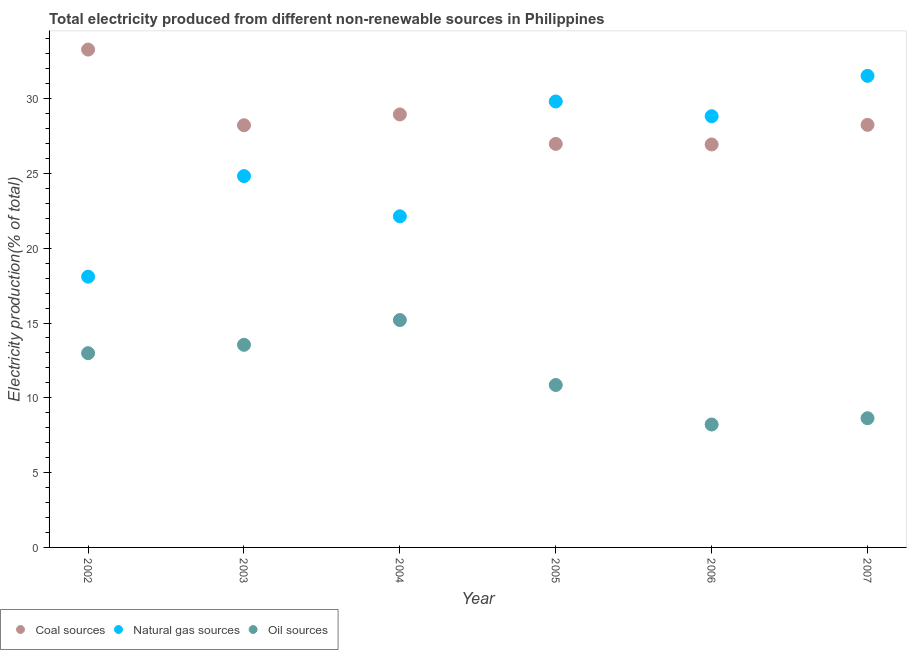How many different coloured dotlines are there?
Provide a short and direct response. 3. What is the percentage of electricity produced by oil sources in 2002?
Your answer should be very brief. 12.98. Across all years, what is the maximum percentage of electricity produced by coal?
Ensure brevity in your answer.  33.28. Across all years, what is the minimum percentage of electricity produced by coal?
Ensure brevity in your answer.  26.93. In which year was the percentage of electricity produced by coal maximum?
Give a very brief answer. 2002. What is the total percentage of electricity produced by coal in the graph?
Ensure brevity in your answer.  172.59. What is the difference between the percentage of electricity produced by natural gas in 2002 and that in 2006?
Ensure brevity in your answer.  -10.73. What is the difference between the percentage of electricity produced by coal in 2007 and the percentage of electricity produced by natural gas in 2006?
Your answer should be very brief. -0.58. What is the average percentage of electricity produced by oil sources per year?
Make the answer very short. 11.57. In the year 2006, what is the difference between the percentage of electricity produced by natural gas and percentage of electricity produced by oil sources?
Give a very brief answer. 20.61. In how many years, is the percentage of electricity produced by natural gas greater than 25 %?
Offer a very short reply. 3. What is the ratio of the percentage of electricity produced by natural gas in 2006 to that in 2007?
Offer a terse response. 0.91. What is the difference between the highest and the second highest percentage of electricity produced by coal?
Give a very brief answer. 4.34. What is the difference between the highest and the lowest percentage of electricity produced by coal?
Your answer should be very brief. 6.34. Is it the case that in every year, the sum of the percentage of electricity produced by coal and percentage of electricity produced by natural gas is greater than the percentage of electricity produced by oil sources?
Keep it short and to the point. Yes. Does the percentage of electricity produced by natural gas monotonically increase over the years?
Offer a terse response. No. Is the percentage of electricity produced by oil sources strictly less than the percentage of electricity produced by coal over the years?
Provide a short and direct response. Yes. What is the difference between two consecutive major ticks on the Y-axis?
Offer a terse response. 5. Are the values on the major ticks of Y-axis written in scientific E-notation?
Your answer should be compact. No. Does the graph contain any zero values?
Give a very brief answer. No. What is the title of the graph?
Offer a very short reply. Total electricity produced from different non-renewable sources in Philippines. Does "Ages 20-50" appear as one of the legend labels in the graph?
Offer a very short reply. No. What is the Electricity production(% of total) of Coal sources in 2002?
Offer a very short reply. 33.28. What is the Electricity production(% of total) in Natural gas sources in 2002?
Offer a terse response. 18.1. What is the Electricity production(% of total) of Oil sources in 2002?
Provide a succinct answer. 12.98. What is the Electricity production(% of total) in Coal sources in 2003?
Your answer should be very brief. 28.22. What is the Electricity production(% of total) in Natural gas sources in 2003?
Your answer should be very brief. 24.82. What is the Electricity production(% of total) in Oil sources in 2003?
Your answer should be very brief. 13.54. What is the Electricity production(% of total) of Coal sources in 2004?
Provide a succinct answer. 28.94. What is the Electricity production(% of total) in Natural gas sources in 2004?
Ensure brevity in your answer.  22.13. What is the Electricity production(% of total) of Oil sources in 2004?
Provide a succinct answer. 15.2. What is the Electricity production(% of total) in Coal sources in 2005?
Offer a terse response. 26.97. What is the Electricity production(% of total) in Natural gas sources in 2005?
Ensure brevity in your answer.  29.81. What is the Electricity production(% of total) in Oil sources in 2005?
Offer a terse response. 10.86. What is the Electricity production(% of total) in Coal sources in 2006?
Give a very brief answer. 26.93. What is the Electricity production(% of total) in Natural gas sources in 2006?
Provide a short and direct response. 28.82. What is the Electricity production(% of total) in Oil sources in 2006?
Your response must be concise. 8.22. What is the Electricity production(% of total) in Coal sources in 2007?
Your answer should be compact. 28.24. What is the Electricity production(% of total) of Natural gas sources in 2007?
Provide a short and direct response. 31.52. What is the Electricity production(% of total) in Oil sources in 2007?
Offer a very short reply. 8.64. Across all years, what is the maximum Electricity production(% of total) in Coal sources?
Your answer should be very brief. 33.28. Across all years, what is the maximum Electricity production(% of total) in Natural gas sources?
Give a very brief answer. 31.52. Across all years, what is the maximum Electricity production(% of total) in Oil sources?
Ensure brevity in your answer.  15.2. Across all years, what is the minimum Electricity production(% of total) of Coal sources?
Offer a terse response. 26.93. Across all years, what is the minimum Electricity production(% of total) of Natural gas sources?
Provide a short and direct response. 18.1. Across all years, what is the minimum Electricity production(% of total) of Oil sources?
Your answer should be very brief. 8.22. What is the total Electricity production(% of total) of Coal sources in the graph?
Ensure brevity in your answer.  172.59. What is the total Electricity production(% of total) of Natural gas sources in the graph?
Ensure brevity in your answer.  155.2. What is the total Electricity production(% of total) in Oil sources in the graph?
Give a very brief answer. 69.43. What is the difference between the Electricity production(% of total) in Coal sources in 2002 and that in 2003?
Make the answer very short. 5.06. What is the difference between the Electricity production(% of total) in Natural gas sources in 2002 and that in 2003?
Give a very brief answer. -6.72. What is the difference between the Electricity production(% of total) of Oil sources in 2002 and that in 2003?
Keep it short and to the point. -0.56. What is the difference between the Electricity production(% of total) of Coal sources in 2002 and that in 2004?
Your answer should be compact. 4.34. What is the difference between the Electricity production(% of total) of Natural gas sources in 2002 and that in 2004?
Your answer should be very brief. -4.03. What is the difference between the Electricity production(% of total) in Oil sources in 2002 and that in 2004?
Ensure brevity in your answer.  -2.21. What is the difference between the Electricity production(% of total) in Coal sources in 2002 and that in 2005?
Provide a short and direct response. 6.3. What is the difference between the Electricity production(% of total) in Natural gas sources in 2002 and that in 2005?
Offer a very short reply. -11.71. What is the difference between the Electricity production(% of total) in Oil sources in 2002 and that in 2005?
Provide a succinct answer. 2.13. What is the difference between the Electricity production(% of total) of Coal sources in 2002 and that in 2006?
Offer a terse response. 6.34. What is the difference between the Electricity production(% of total) in Natural gas sources in 2002 and that in 2006?
Make the answer very short. -10.73. What is the difference between the Electricity production(% of total) of Oil sources in 2002 and that in 2006?
Your response must be concise. 4.77. What is the difference between the Electricity production(% of total) in Coal sources in 2002 and that in 2007?
Your answer should be very brief. 5.03. What is the difference between the Electricity production(% of total) of Natural gas sources in 2002 and that in 2007?
Your response must be concise. -13.42. What is the difference between the Electricity production(% of total) in Oil sources in 2002 and that in 2007?
Your response must be concise. 4.35. What is the difference between the Electricity production(% of total) of Coal sources in 2003 and that in 2004?
Make the answer very short. -0.72. What is the difference between the Electricity production(% of total) of Natural gas sources in 2003 and that in 2004?
Make the answer very short. 2.69. What is the difference between the Electricity production(% of total) in Oil sources in 2003 and that in 2004?
Offer a terse response. -1.65. What is the difference between the Electricity production(% of total) of Coal sources in 2003 and that in 2005?
Offer a terse response. 1.25. What is the difference between the Electricity production(% of total) in Natural gas sources in 2003 and that in 2005?
Provide a succinct answer. -4.99. What is the difference between the Electricity production(% of total) in Oil sources in 2003 and that in 2005?
Provide a short and direct response. 2.69. What is the difference between the Electricity production(% of total) of Coal sources in 2003 and that in 2006?
Give a very brief answer. 1.28. What is the difference between the Electricity production(% of total) of Natural gas sources in 2003 and that in 2006?
Your answer should be very brief. -4. What is the difference between the Electricity production(% of total) in Oil sources in 2003 and that in 2006?
Give a very brief answer. 5.33. What is the difference between the Electricity production(% of total) in Coal sources in 2003 and that in 2007?
Ensure brevity in your answer.  -0.03. What is the difference between the Electricity production(% of total) in Natural gas sources in 2003 and that in 2007?
Offer a very short reply. -6.7. What is the difference between the Electricity production(% of total) of Oil sources in 2003 and that in 2007?
Ensure brevity in your answer.  4.91. What is the difference between the Electricity production(% of total) in Coal sources in 2004 and that in 2005?
Offer a terse response. 1.97. What is the difference between the Electricity production(% of total) in Natural gas sources in 2004 and that in 2005?
Ensure brevity in your answer.  -7.68. What is the difference between the Electricity production(% of total) of Oil sources in 2004 and that in 2005?
Your answer should be compact. 4.34. What is the difference between the Electricity production(% of total) in Coal sources in 2004 and that in 2006?
Keep it short and to the point. 2.01. What is the difference between the Electricity production(% of total) in Natural gas sources in 2004 and that in 2006?
Provide a short and direct response. -6.69. What is the difference between the Electricity production(% of total) in Oil sources in 2004 and that in 2006?
Provide a succinct answer. 6.98. What is the difference between the Electricity production(% of total) of Coal sources in 2004 and that in 2007?
Give a very brief answer. 0.7. What is the difference between the Electricity production(% of total) in Natural gas sources in 2004 and that in 2007?
Offer a very short reply. -9.39. What is the difference between the Electricity production(% of total) in Oil sources in 2004 and that in 2007?
Offer a terse response. 6.56. What is the difference between the Electricity production(% of total) in Coal sources in 2005 and that in 2006?
Your answer should be very brief. 0.04. What is the difference between the Electricity production(% of total) in Natural gas sources in 2005 and that in 2006?
Your response must be concise. 0.99. What is the difference between the Electricity production(% of total) in Oil sources in 2005 and that in 2006?
Give a very brief answer. 2.64. What is the difference between the Electricity production(% of total) in Coal sources in 2005 and that in 2007?
Give a very brief answer. -1.27. What is the difference between the Electricity production(% of total) of Natural gas sources in 2005 and that in 2007?
Offer a very short reply. -1.71. What is the difference between the Electricity production(% of total) of Oil sources in 2005 and that in 2007?
Your answer should be compact. 2.22. What is the difference between the Electricity production(% of total) of Coal sources in 2006 and that in 2007?
Provide a short and direct response. -1.31. What is the difference between the Electricity production(% of total) in Natural gas sources in 2006 and that in 2007?
Give a very brief answer. -2.7. What is the difference between the Electricity production(% of total) of Oil sources in 2006 and that in 2007?
Provide a short and direct response. -0.42. What is the difference between the Electricity production(% of total) of Coal sources in 2002 and the Electricity production(% of total) of Natural gas sources in 2003?
Offer a terse response. 8.46. What is the difference between the Electricity production(% of total) in Coal sources in 2002 and the Electricity production(% of total) in Oil sources in 2003?
Keep it short and to the point. 19.73. What is the difference between the Electricity production(% of total) in Natural gas sources in 2002 and the Electricity production(% of total) in Oil sources in 2003?
Your answer should be very brief. 4.55. What is the difference between the Electricity production(% of total) of Coal sources in 2002 and the Electricity production(% of total) of Natural gas sources in 2004?
Make the answer very short. 11.14. What is the difference between the Electricity production(% of total) of Coal sources in 2002 and the Electricity production(% of total) of Oil sources in 2004?
Make the answer very short. 18.08. What is the difference between the Electricity production(% of total) in Natural gas sources in 2002 and the Electricity production(% of total) in Oil sources in 2004?
Your answer should be compact. 2.9. What is the difference between the Electricity production(% of total) of Coal sources in 2002 and the Electricity production(% of total) of Natural gas sources in 2005?
Give a very brief answer. 3.47. What is the difference between the Electricity production(% of total) in Coal sources in 2002 and the Electricity production(% of total) in Oil sources in 2005?
Your response must be concise. 22.42. What is the difference between the Electricity production(% of total) of Natural gas sources in 2002 and the Electricity production(% of total) of Oil sources in 2005?
Ensure brevity in your answer.  7.24. What is the difference between the Electricity production(% of total) of Coal sources in 2002 and the Electricity production(% of total) of Natural gas sources in 2006?
Offer a terse response. 4.45. What is the difference between the Electricity production(% of total) of Coal sources in 2002 and the Electricity production(% of total) of Oil sources in 2006?
Give a very brief answer. 25.06. What is the difference between the Electricity production(% of total) of Natural gas sources in 2002 and the Electricity production(% of total) of Oil sources in 2006?
Keep it short and to the point. 9.88. What is the difference between the Electricity production(% of total) of Coal sources in 2002 and the Electricity production(% of total) of Natural gas sources in 2007?
Ensure brevity in your answer.  1.76. What is the difference between the Electricity production(% of total) of Coal sources in 2002 and the Electricity production(% of total) of Oil sources in 2007?
Offer a terse response. 24.64. What is the difference between the Electricity production(% of total) of Natural gas sources in 2002 and the Electricity production(% of total) of Oil sources in 2007?
Keep it short and to the point. 9.46. What is the difference between the Electricity production(% of total) in Coal sources in 2003 and the Electricity production(% of total) in Natural gas sources in 2004?
Make the answer very short. 6.09. What is the difference between the Electricity production(% of total) of Coal sources in 2003 and the Electricity production(% of total) of Oil sources in 2004?
Keep it short and to the point. 13.02. What is the difference between the Electricity production(% of total) of Natural gas sources in 2003 and the Electricity production(% of total) of Oil sources in 2004?
Make the answer very short. 9.62. What is the difference between the Electricity production(% of total) of Coal sources in 2003 and the Electricity production(% of total) of Natural gas sources in 2005?
Ensure brevity in your answer.  -1.59. What is the difference between the Electricity production(% of total) in Coal sources in 2003 and the Electricity production(% of total) in Oil sources in 2005?
Your response must be concise. 17.36. What is the difference between the Electricity production(% of total) in Natural gas sources in 2003 and the Electricity production(% of total) in Oil sources in 2005?
Your response must be concise. 13.96. What is the difference between the Electricity production(% of total) in Coal sources in 2003 and the Electricity production(% of total) in Natural gas sources in 2006?
Offer a terse response. -0.6. What is the difference between the Electricity production(% of total) in Coal sources in 2003 and the Electricity production(% of total) in Oil sources in 2006?
Offer a very short reply. 20. What is the difference between the Electricity production(% of total) of Natural gas sources in 2003 and the Electricity production(% of total) of Oil sources in 2006?
Provide a succinct answer. 16.6. What is the difference between the Electricity production(% of total) in Coal sources in 2003 and the Electricity production(% of total) in Natural gas sources in 2007?
Make the answer very short. -3.3. What is the difference between the Electricity production(% of total) of Coal sources in 2003 and the Electricity production(% of total) of Oil sources in 2007?
Provide a short and direct response. 19.58. What is the difference between the Electricity production(% of total) of Natural gas sources in 2003 and the Electricity production(% of total) of Oil sources in 2007?
Your answer should be very brief. 16.18. What is the difference between the Electricity production(% of total) of Coal sources in 2004 and the Electricity production(% of total) of Natural gas sources in 2005?
Keep it short and to the point. -0.87. What is the difference between the Electricity production(% of total) in Coal sources in 2004 and the Electricity production(% of total) in Oil sources in 2005?
Provide a succinct answer. 18.08. What is the difference between the Electricity production(% of total) in Natural gas sources in 2004 and the Electricity production(% of total) in Oil sources in 2005?
Your response must be concise. 11.28. What is the difference between the Electricity production(% of total) of Coal sources in 2004 and the Electricity production(% of total) of Natural gas sources in 2006?
Keep it short and to the point. 0.12. What is the difference between the Electricity production(% of total) in Coal sources in 2004 and the Electricity production(% of total) in Oil sources in 2006?
Your answer should be very brief. 20.72. What is the difference between the Electricity production(% of total) of Natural gas sources in 2004 and the Electricity production(% of total) of Oil sources in 2006?
Provide a succinct answer. 13.92. What is the difference between the Electricity production(% of total) of Coal sources in 2004 and the Electricity production(% of total) of Natural gas sources in 2007?
Your answer should be compact. -2.58. What is the difference between the Electricity production(% of total) of Coal sources in 2004 and the Electricity production(% of total) of Oil sources in 2007?
Provide a short and direct response. 20.3. What is the difference between the Electricity production(% of total) of Natural gas sources in 2004 and the Electricity production(% of total) of Oil sources in 2007?
Make the answer very short. 13.5. What is the difference between the Electricity production(% of total) of Coal sources in 2005 and the Electricity production(% of total) of Natural gas sources in 2006?
Keep it short and to the point. -1.85. What is the difference between the Electricity production(% of total) in Coal sources in 2005 and the Electricity production(% of total) in Oil sources in 2006?
Your answer should be very brief. 18.76. What is the difference between the Electricity production(% of total) in Natural gas sources in 2005 and the Electricity production(% of total) in Oil sources in 2006?
Your answer should be compact. 21.59. What is the difference between the Electricity production(% of total) of Coal sources in 2005 and the Electricity production(% of total) of Natural gas sources in 2007?
Offer a terse response. -4.55. What is the difference between the Electricity production(% of total) of Coal sources in 2005 and the Electricity production(% of total) of Oil sources in 2007?
Provide a short and direct response. 18.34. What is the difference between the Electricity production(% of total) in Natural gas sources in 2005 and the Electricity production(% of total) in Oil sources in 2007?
Your response must be concise. 21.17. What is the difference between the Electricity production(% of total) in Coal sources in 2006 and the Electricity production(% of total) in Natural gas sources in 2007?
Provide a short and direct response. -4.59. What is the difference between the Electricity production(% of total) in Coal sources in 2006 and the Electricity production(% of total) in Oil sources in 2007?
Offer a very short reply. 18.3. What is the difference between the Electricity production(% of total) of Natural gas sources in 2006 and the Electricity production(% of total) of Oil sources in 2007?
Provide a succinct answer. 20.19. What is the average Electricity production(% of total) of Coal sources per year?
Offer a terse response. 28.76. What is the average Electricity production(% of total) in Natural gas sources per year?
Make the answer very short. 25.87. What is the average Electricity production(% of total) in Oil sources per year?
Your answer should be very brief. 11.57. In the year 2002, what is the difference between the Electricity production(% of total) in Coal sources and Electricity production(% of total) in Natural gas sources?
Your response must be concise. 15.18. In the year 2002, what is the difference between the Electricity production(% of total) in Coal sources and Electricity production(% of total) in Oil sources?
Give a very brief answer. 20.29. In the year 2002, what is the difference between the Electricity production(% of total) in Natural gas sources and Electricity production(% of total) in Oil sources?
Provide a succinct answer. 5.11. In the year 2003, what is the difference between the Electricity production(% of total) of Coal sources and Electricity production(% of total) of Natural gas sources?
Provide a short and direct response. 3.4. In the year 2003, what is the difference between the Electricity production(% of total) in Coal sources and Electricity production(% of total) in Oil sources?
Make the answer very short. 14.68. In the year 2003, what is the difference between the Electricity production(% of total) of Natural gas sources and Electricity production(% of total) of Oil sources?
Keep it short and to the point. 11.28. In the year 2004, what is the difference between the Electricity production(% of total) in Coal sources and Electricity production(% of total) in Natural gas sources?
Provide a succinct answer. 6.81. In the year 2004, what is the difference between the Electricity production(% of total) of Coal sources and Electricity production(% of total) of Oil sources?
Make the answer very short. 13.74. In the year 2004, what is the difference between the Electricity production(% of total) of Natural gas sources and Electricity production(% of total) of Oil sources?
Provide a short and direct response. 6.93. In the year 2005, what is the difference between the Electricity production(% of total) of Coal sources and Electricity production(% of total) of Natural gas sources?
Provide a succinct answer. -2.84. In the year 2005, what is the difference between the Electricity production(% of total) of Coal sources and Electricity production(% of total) of Oil sources?
Offer a terse response. 16.12. In the year 2005, what is the difference between the Electricity production(% of total) of Natural gas sources and Electricity production(% of total) of Oil sources?
Provide a short and direct response. 18.95. In the year 2006, what is the difference between the Electricity production(% of total) of Coal sources and Electricity production(% of total) of Natural gas sources?
Provide a succinct answer. -1.89. In the year 2006, what is the difference between the Electricity production(% of total) in Coal sources and Electricity production(% of total) in Oil sources?
Make the answer very short. 18.72. In the year 2006, what is the difference between the Electricity production(% of total) of Natural gas sources and Electricity production(% of total) of Oil sources?
Your answer should be very brief. 20.61. In the year 2007, what is the difference between the Electricity production(% of total) of Coal sources and Electricity production(% of total) of Natural gas sources?
Offer a very short reply. -3.27. In the year 2007, what is the difference between the Electricity production(% of total) in Coal sources and Electricity production(% of total) in Oil sources?
Make the answer very short. 19.61. In the year 2007, what is the difference between the Electricity production(% of total) of Natural gas sources and Electricity production(% of total) of Oil sources?
Your response must be concise. 22.88. What is the ratio of the Electricity production(% of total) in Coal sources in 2002 to that in 2003?
Your answer should be very brief. 1.18. What is the ratio of the Electricity production(% of total) in Natural gas sources in 2002 to that in 2003?
Offer a very short reply. 0.73. What is the ratio of the Electricity production(% of total) in Oil sources in 2002 to that in 2003?
Your answer should be very brief. 0.96. What is the ratio of the Electricity production(% of total) of Coal sources in 2002 to that in 2004?
Ensure brevity in your answer.  1.15. What is the ratio of the Electricity production(% of total) of Natural gas sources in 2002 to that in 2004?
Give a very brief answer. 0.82. What is the ratio of the Electricity production(% of total) of Oil sources in 2002 to that in 2004?
Provide a short and direct response. 0.85. What is the ratio of the Electricity production(% of total) of Coal sources in 2002 to that in 2005?
Offer a very short reply. 1.23. What is the ratio of the Electricity production(% of total) in Natural gas sources in 2002 to that in 2005?
Your answer should be very brief. 0.61. What is the ratio of the Electricity production(% of total) in Oil sources in 2002 to that in 2005?
Offer a terse response. 1.2. What is the ratio of the Electricity production(% of total) of Coal sources in 2002 to that in 2006?
Provide a short and direct response. 1.24. What is the ratio of the Electricity production(% of total) of Natural gas sources in 2002 to that in 2006?
Give a very brief answer. 0.63. What is the ratio of the Electricity production(% of total) of Oil sources in 2002 to that in 2006?
Provide a succinct answer. 1.58. What is the ratio of the Electricity production(% of total) of Coal sources in 2002 to that in 2007?
Your response must be concise. 1.18. What is the ratio of the Electricity production(% of total) of Natural gas sources in 2002 to that in 2007?
Keep it short and to the point. 0.57. What is the ratio of the Electricity production(% of total) of Oil sources in 2002 to that in 2007?
Ensure brevity in your answer.  1.5. What is the ratio of the Electricity production(% of total) in Coal sources in 2003 to that in 2004?
Offer a very short reply. 0.98. What is the ratio of the Electricity production(% of total) of Natural gas sources in 2003 to that in 2004?
Ensure brevity in your answer.  1.12. What is the ratio of the Electricity production(% of total) in Oil sources in 2003 to that in 2004?
Keep it short and to the point. 0.89. What is the ratio of the Electricity production(% of total) in Coal sources in 2003 to that in 2005?
Your response must be concise. 1.05. What is the ratio of the Electricity production(% of total) in Natural gas sources in 2003 to that in 2005?
Ensure brevity in your answer.  0.83. What is the ratio of the Electricity production(% of total) in Oil sources in 2003 to that in 2005?
Provide a succinct answer. 1.25. What is the ratio of the Electricity production(% of total) in Coal sources in 2003 to that in 2006?
Make the answer very short. 1.05. What is the ratio of the Electricity production(% of total) of Natural gas sources in 2003 to that in 2006?
Provide a short and direct response. 0.86. What is the ratio of the Electricity production(% of total) of Oil sources in 2003 to that in 2006?
Provide a succinct answer. 1.65. What is the ratio of the Electricity production(% of total) in Natural gas sources in 2003 to that in 2007?
Your answer should be very brief. 0.79. What is the ratio of the Electricity production(% of total) in Oil sources in 2003 to that in 2007?
Your answer should be compact. 1.57. What is the ratio of the Electricity production(% of total) in Coal sources in 2004 to that in 2005?
Provide a short and direct response. 1.07. What is the ratio of the Electricity production(% of total) of Natural gas sources in 2004 to that in 2005?
Give a very brief answer. 0.74. What is the ratio of the Electricity production(% of total) in Oil sources in 2004 to that in 2005?
Keep it short and to the point. 1.4. What is the ratio of the Electricity production(% of total) of Coal sources in 2004 to that in 2006?
Offer a terse response. 1.07. What is the ratio of the Electricity production(% of total) of Natural gas sources in 2004 to that in 2006?
Make the answer very short. 0.77. What is the ratio of the Electricity production(% of total) of Oil sources in 2004 to that in 2006?
Ensure brevity in your answer.  1.85. What is the ratio of the Electricity production(% of total) in Coal sources in 2004 to that in 2007?
Give a very brief answer. 1.02. What is the ratio of the Electricity production(% of total) in Natural gas sources in 2004 to that in 2007?
Offer a very short reply. 0.7. What is the ratio of the Electricity production(% of total) of Oil sources in 2004 to that in 2007?
Give a very brief answer. 1.76. What is the ratio of the Electricity production(% of total) in Natural gas sources in 2005 to that in 2006?
Give a very brief answer. 1.03. What is the ratio of the Electricity production(% of total) of Oil sources in 2005 to that in 2006?
Provide a short and direct response. 1.32. What is the ratio of the Electricity production(% of total) of Coal sources in 2005 to that in 2007?
Keep it short and to the point. 0.95. What is the ratio of the Electricity production(% of total) in Natural gas sources in 2005 to that in 2007?
Offer a terse response. 0.95. What is the ratio of the Electricity production(% of total) of Oil sources in 2005 to that in 2007?
Keep it short and to the point. 1.26. What is the ratio of the Electricity production(% of total) of Coal sources in 2006 to that in 2007?
Provide a short and direct response. 0.95. What is the ratio of the Electricity production(% of total) of Natural gas sources in 2006 to that in 2007?
Offer a very short reply. 0.91. What is the ratio of the Electricity production(% of total) of Oil sources in 2006 to that in 2007?
Offer a terse response. 0.95. What is the difference between the highest and the second highest Electricity production(% of total) in Coal sources?
Provide a short and direct response. 4.34. What is the difference between the highest and the second highest Electricity production(% of total) of Natural gas sources?
Keep it short and to the point. 1.71. What is the difference between the highest and the second highest Electricity production(% of total) of Oil sources?
Your answer should be very brief. 1.65. What is the difference between the highest and the lowest Electricity production(% of total) in Coal sources?
Your response must be concise. 6.34. What is the difference between the highest and the lowest Electricity production(% of total) of Natural gas sources?
Provide a short and direct response. 13.42. What is the difference between the highest and the lowest Electricity production(% of total) of Oil sources?
Give a very brief answer. 6.98. 